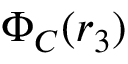Convert formula to latex. <formula><loc_0><loc_0><loc_500><loc_500>\Phi _ { C } ( r _ { 3 } )</formula> 